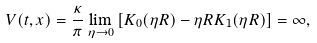<formula> <loc_0><loc_0><loc_500><loc_500>V ( t , x ) = \frac { \kappa } { \pi } \lim _ { \eta \rightarrow 0 } \left [ K _ { 0 } ( \eta R ) - \eta R K _ { 1 } ( \eta R ) \right ] = \infty ,</formula> 